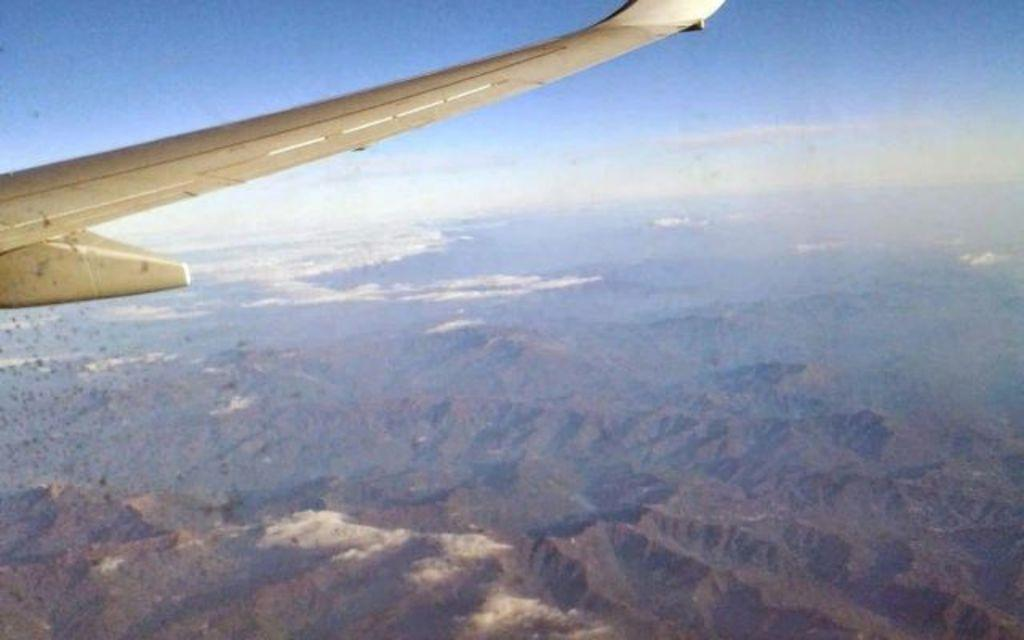What is the main subject of the image? The main subject of the image is an aircraft. What other elements can be seen in the image besides the aircraft? There are trees, mountains, and the sky visible in the image. Can you describe the time of day the image may have been taken? The image may have been taken in the evening, as suggested by the presence of the sky. What type of action is the ticket performing in the image? There is no ticket present in the image, so it cannot perform any action. 